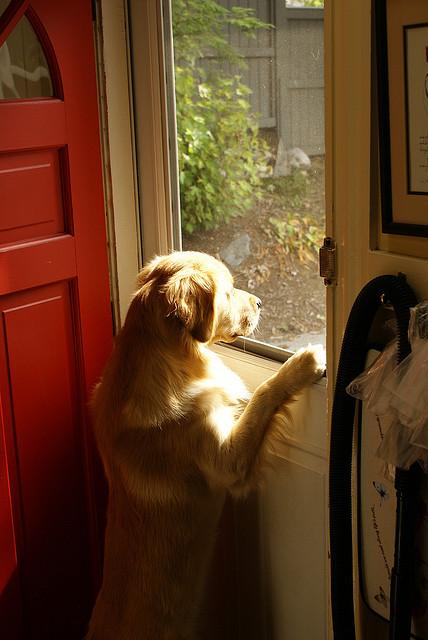Is the dog on all four legs?
Short answer required. No. Is the dog wearing a collar?
Write a very short answer. No. What color is the wooden door?
Give a very brief answer. Red. What is the dog being reflected in?
Quick response, please. Window. What kind of board is the dog standing on?
Concise answer only. Door. What color is the dog?
Answer briefly. Yellow. How many dogs?
Be succinct. 1. 